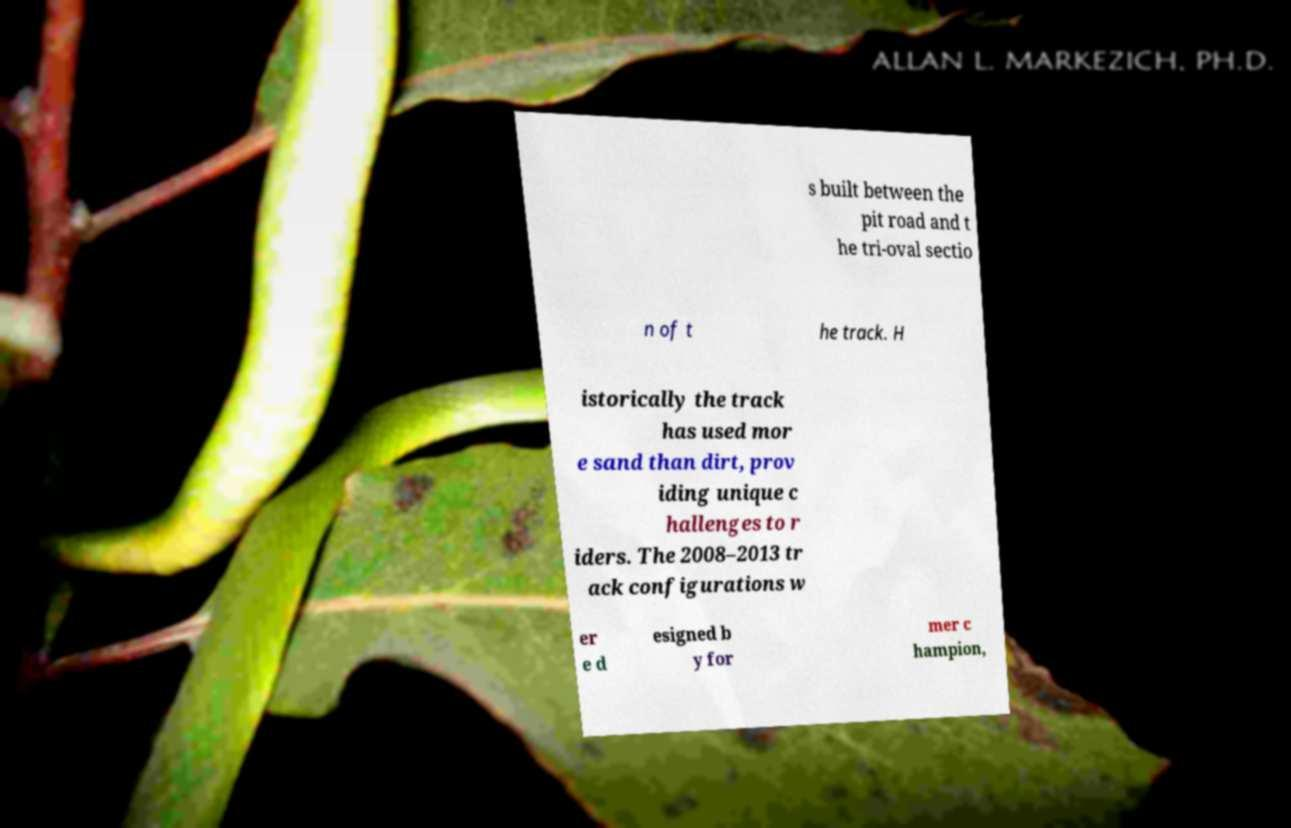There's text embedded in this image that I need extracted. Can you transcribe it verbatim? s built between the pit road and t he tri-oval sectio n of t he track. H istorically the track has used mor e sand than dirt, prov iding unique c hallenges to r iders. The 2008–2013 tr ack configurations w er e d esigned b y for mer c hampion, 